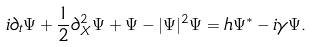<formula> <loc_0><loc_0><loc_500><loc_500>i \partial _ { t } \Psi + { \frac { 1 } { 2 } } \partial _ { X } ^ { 2 } \Psi + \Psi - | \Psi | ^ { 2 } \Psi = h \Psi ^ { * } - i \gamma \Psi .</formula> 